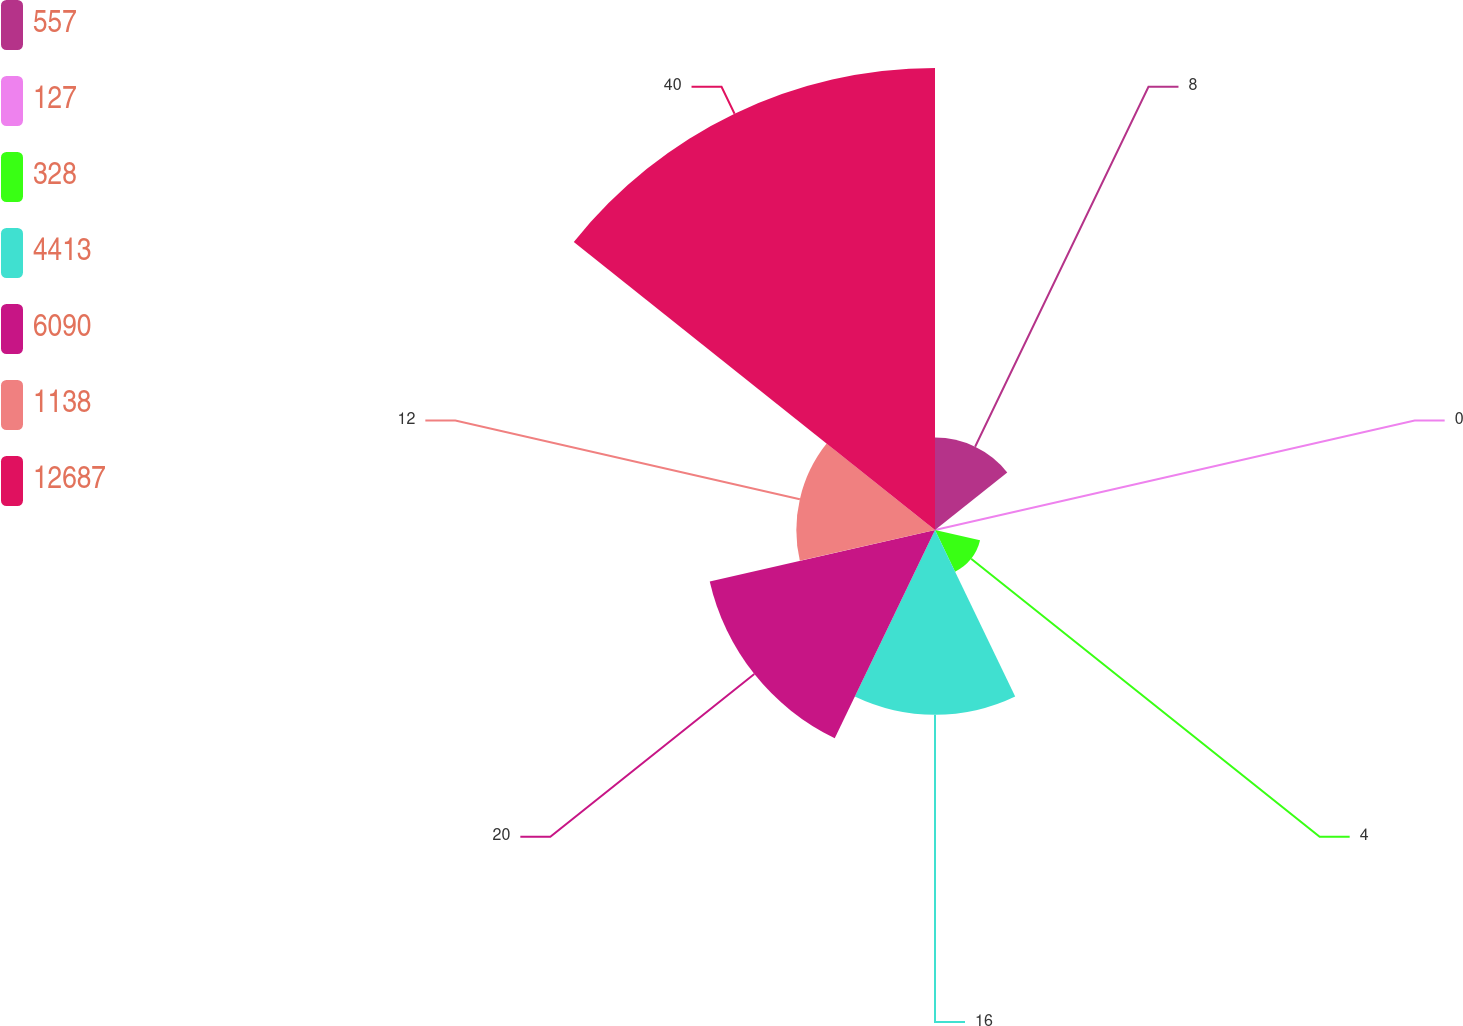Convert chart. <chart><loc_0><loc_0><loc_500><loc_500><pie_chart><fcel>557<fcel>127<fcel>328<fcel>4413<fcel>6090<fcel>1138<fcel>12687<nl><fcel>8.0%<fcel>0.0%<fcel>4.0%<fcel>16.0%<fcel>20.0%<fcel>12.0%<fcel>39.99%<nl></chart> 